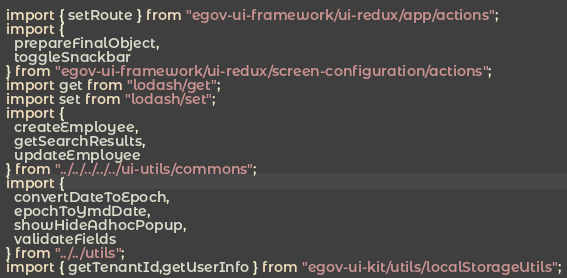Convert code to text. <code><loc_0><loc_0><loc_500><loc_500><_JavaScript_>import { setRoute } from "egov-ui-framework/ui-redux/app/actions";
import {
  prepareFinalObject,
  toggleSnackbar
} from "egov-ui-framework/ui-redux/screen-configuration/actions";
import get from "lodash/get";
import set from "lodash/set";
import {
  createEmployee,
  getSearchResults,
  updateEmployee
} from "../../../../../ui-utils/commons";
import {
  convertDateToEpoch,
  epochToYmdDate,
  showHideAdhocPopup,
  validateFields
} from "../../utils";
import { getTenantId,getUserInfo } from "egov-ui-kit/utils/localStorageUtils";</code> 